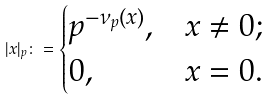Convert formula to latex. <formula><loc_0><loc_0><loc_500><loc_500>| x | _ { p } \colon = \begin{cases} p ^ { - \nu _ { p } ( x ) } , & x \neq 0 ; \\ 0 , & x = 0 . \end{cases}</formula> 